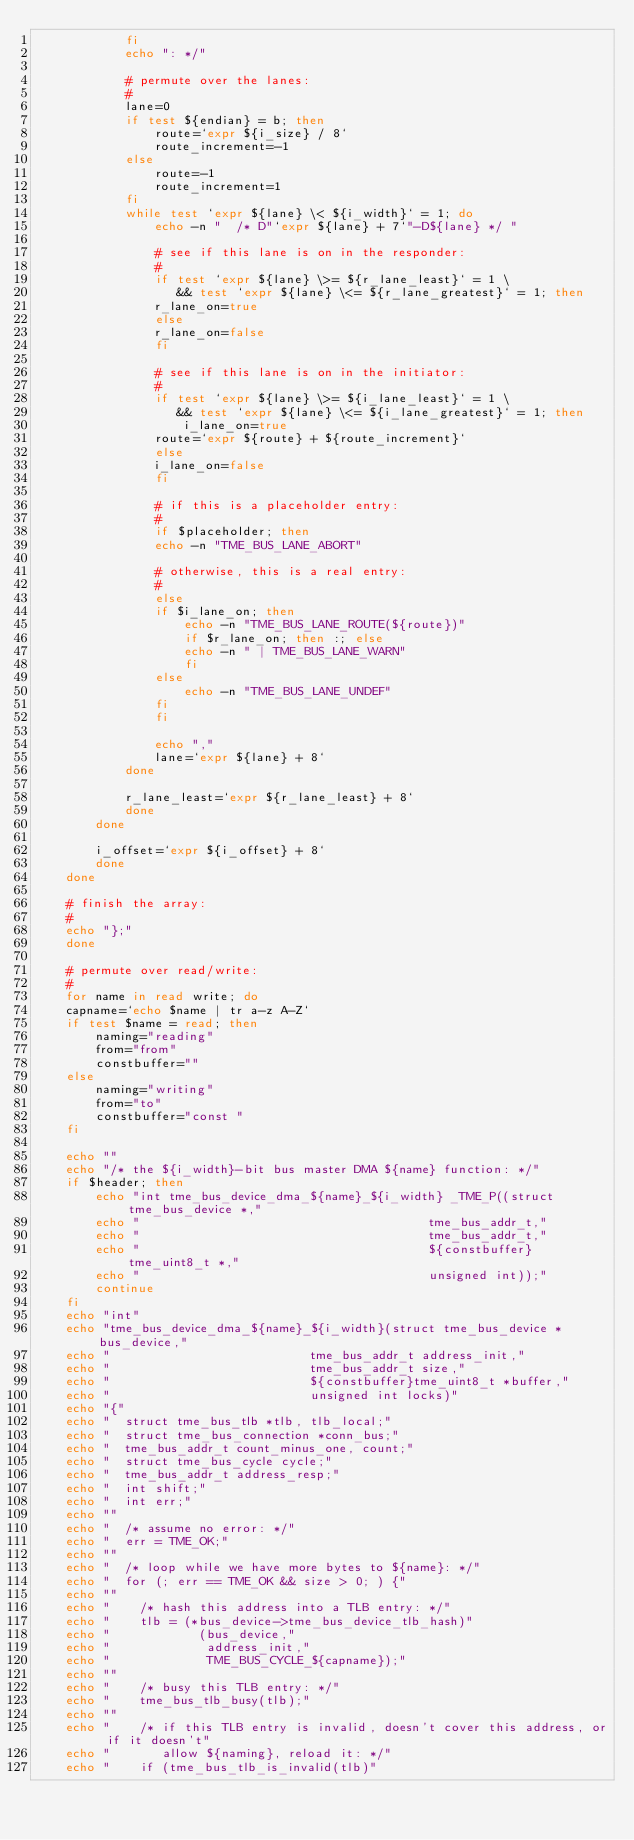<code> <loc_0><loc_0><loc_500><loc_500><_Bash_>			fi
			echo ": */"

			# permute over the lanes:
			#
			lane=0
			if test ${endian} = b; then
			    route=`expr ${i_size} / 8`
			    route_increment=-1
			else
			    route=-1
			    route_increment=1
			fi
			while test `expr ${lane} \< ${i_width}` = 1; do
			    echo -n "  /* D"`expr ${lane} + 7`"-D${lane} */	"

			    # see if this lane is on in the responder:
			    #
			    if test `expr ${lane} \>= ${r_lane_least}` = 1 \
			       && test `expr ${lane} \<= ${r_lane_greatest}` = 1; then
				r_lane_on=true
			    else
				r_lane_on=false
			    fi

			    # see if this lane is on in the initiator:
			    #
			    if test `expr ${lane} \>= ${i_lane_least}` = 1 \
			       && test `expr ${lane} \<= ${i_lane_greatest}` = 1; then
			        i_lane_on=true
				route=`expr ${route} + ${route_increment}`
			    else
				i_lane_on=false
			    fi

			    # if this is a placeholder entry:
			    #
			    if $placeholder; then
				echo -n "TME_BUS_LANE_ABORT"

			    # otherwise, this is a real entry:
			    #
			    else
				if $i_lane_on; then
				    echo -n "TME_BUS_LANE_ROUTE(${route})"
				    if $r_lane_on; then :; else
					echo -n " | TME_BUS_LANE_WARN"
				    fi
				else
				    echo -n "TME_BUS_LANE_UNDEF"
				fi
			    fi

			    echo ","
			    lane=`expr ${lane} + 8`
			done

			r_lane_least=`expr ${r_lane_least} + 8`
		    done
		done
		
		i_offset=`expr ${i_offset} + 8`
	    done
	done

	# finish the array:
	#
	echo "};"
    done

    # permute over read/write:
    #
    for name in read write; do
	capname=`echo $name | tr a-z A-Z`
	if test $name = read; then 
	    naming="reading"
	    from="from"
	    constbuffer=""
	else
	    naming="writing"
	    from="to"
	    constbuffer="const "
	fi

	echo ""
	echo "/* the ${i_width}-bit bus master DMA ${name} function: */"
	if $header; then
	    echo "int tme_bus_device_dma_${name}_${i_width} _TME_P((struct tme_bus_device *,"
	    echo "                                       tme_bus_addr_t,"
	    echo "                                       tme_bus_addr_t,"
	    echo "                                       ${constbuffer}tme_uint8_t *,"
	    echo "                                       unsigned int));"
	    continue
	fi
	echo "int"
	echo "tme_bus_device_dma_${name}_${i_width}(struct tme_bus_device *bus_device,"
	echo "                           tme_bus_addr_t address_init,"
	echo "                           tme_bus_addr_t size,"
	echo "                           ${constbuffer}tme_uint8_t *buffer,"
	echo "                           unsigned int locks)"
	echo "{"
	echo "  struct tme_bus_tlb *tlb, tlb_local;"
	echo "  struct tme_bus_connection *conn_bus;"
	echo "  tme_bus_addr_t count_minus_one, count;"
	echo "  struct tme_bus_cycle cycle;"
	echo "  tme_bus_addr_t address_resp;"
	echo "  int shift;"
	echo "  int err;"
	echo ""
	echo "  /* assume no error: */"
	echo "  err = TME_OK;"
	echo ""
	echo "  /* loop while we have more bytes to ${name}: */"
	echo "  for (; err == TME_OK && size > 0; ) {"
	echo ""
	echo "    /* hash this address into a TLB entry: */"
	echo "    tlb = (*bus_device->tme_bus_device_tlb_hash)"
	echo "            (bus_device,"
	echo "             address_init,"
	echo "             TME_BUS_CYCLE_${capname});"
	echo ""
	echo "    /* busy this TLB entry: */"
	echo "    tme_bus_tlb_busy(tlb);"
	echo ""
	echo "    /* if this TLB entry is invalid, doesn't cover this address, or if it doesn't"
	echo "       allow ${naming}, reload it: */"
	echo "    if (tme_bus_tlb_is_invalid(tlb)"</code> 